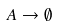<formula> <loc_0><loc_0><loc_500><loc_500>A \to \emptyset</formula> 